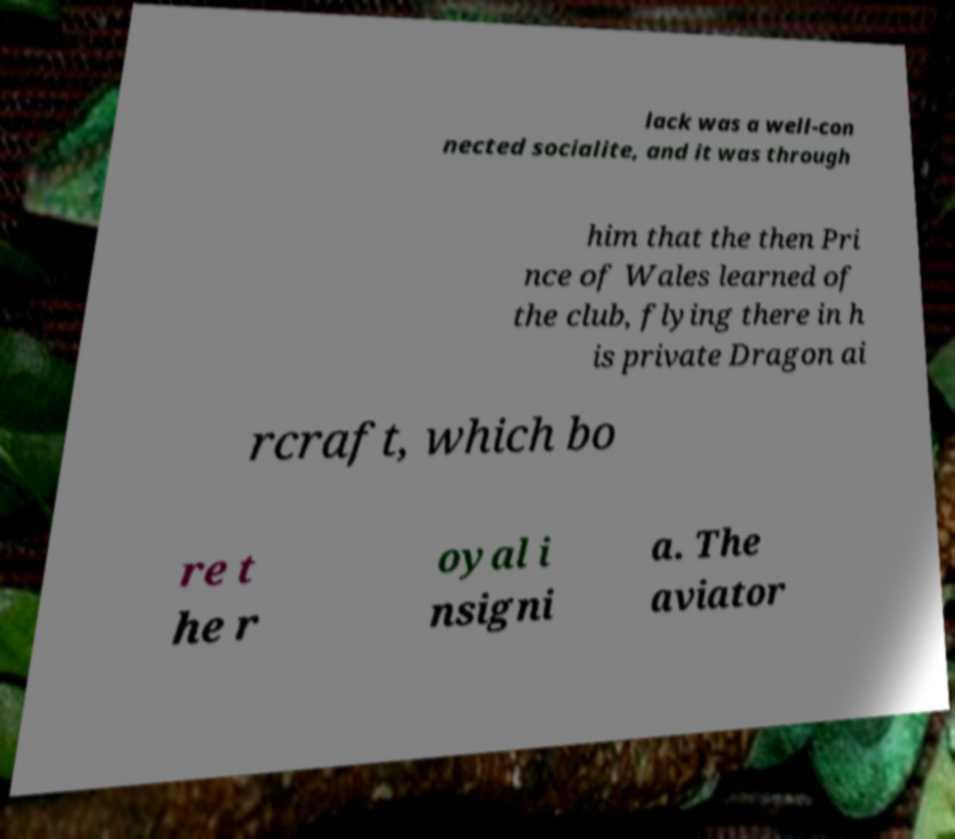There's text embedded in this image that I need extracted. Can you transcribe it verbatim? lack was a well-con nected socialite, and it was through him that the then Pri nce of Wales learned of the club, flying there in h is private Dragon ai rcraft, which bo re t he r oyal i nsigni a. The aviator 